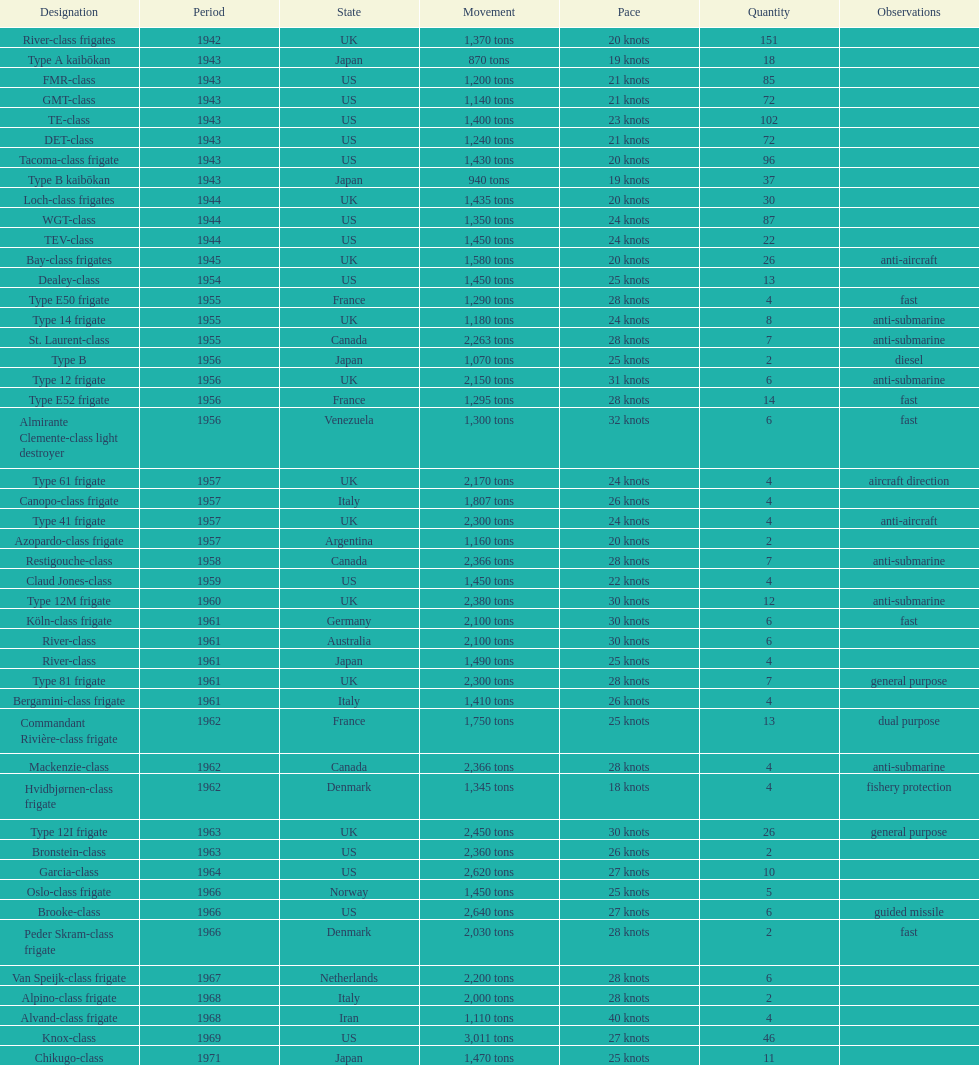What is the difference in speed for the gmt-class and the te-class? 2 knots. 